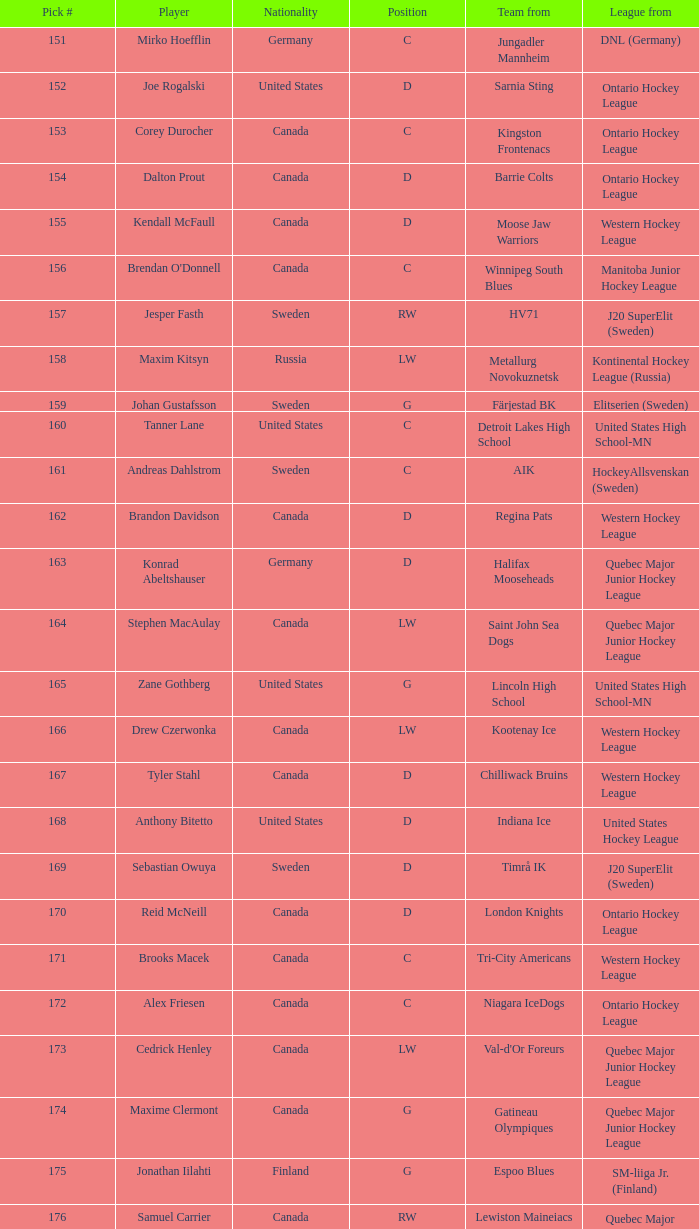Which association possesses the selection #160? United States High School-MN. 